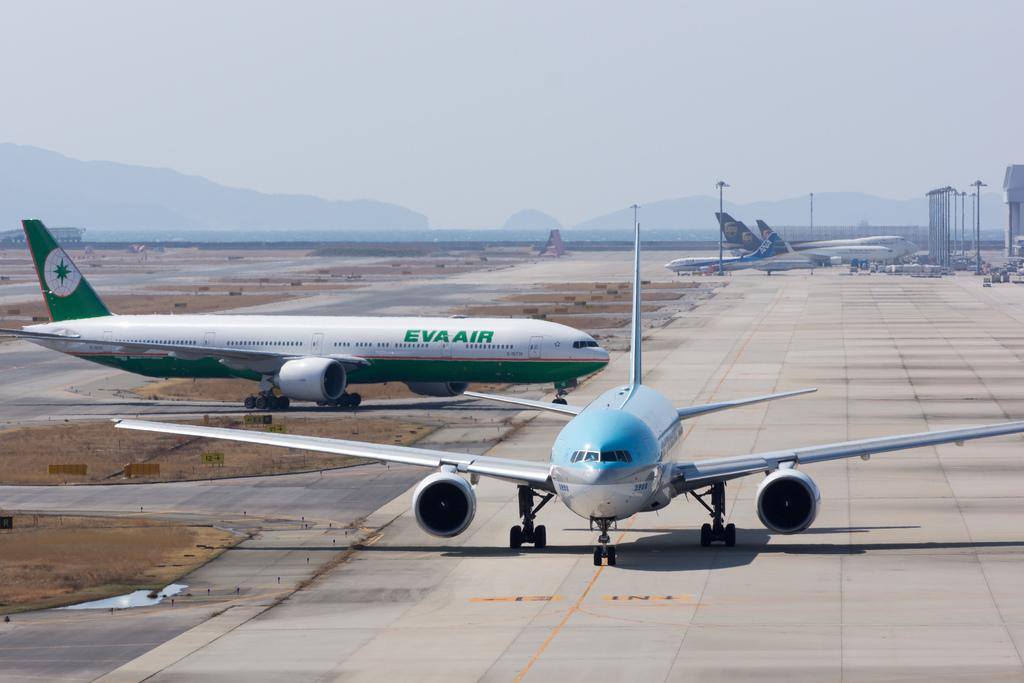<image>
Describe the image concisely. the eva air plane is on a runway with other planes 